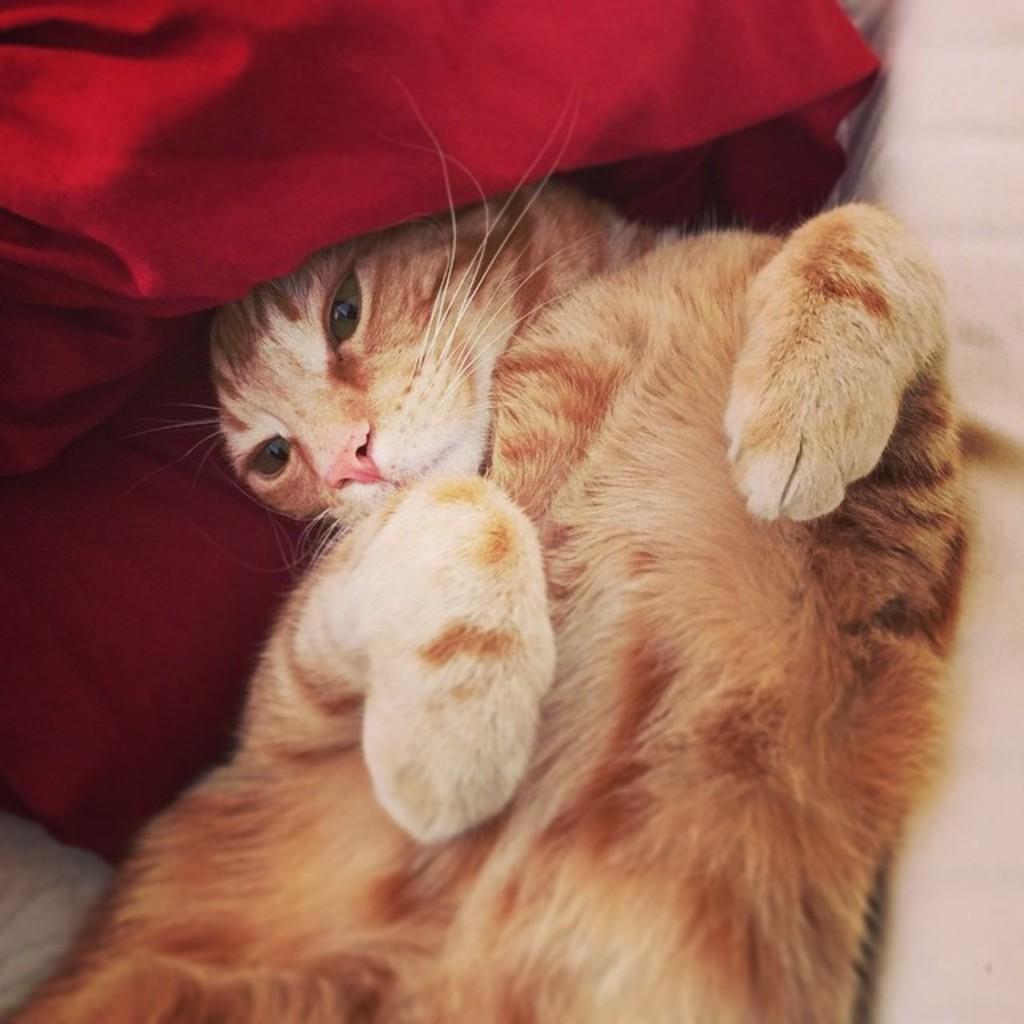In one or two sentences, can you explain what this image depicts? In this image we can see a cat, behind the cat we can see the red color cloth, on the right side of the image we can see an object, which looks like a table. 